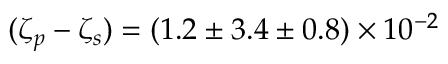<formula> <loc_0><loc_0><loc_500><loc_500>( \zeta _ { p } - \zeta _ { s } ) = ( 1 . 2 \pm 3 . 4 \pm 0 . 8 ) \times 1 0 ^ { - 2 }</formula> 